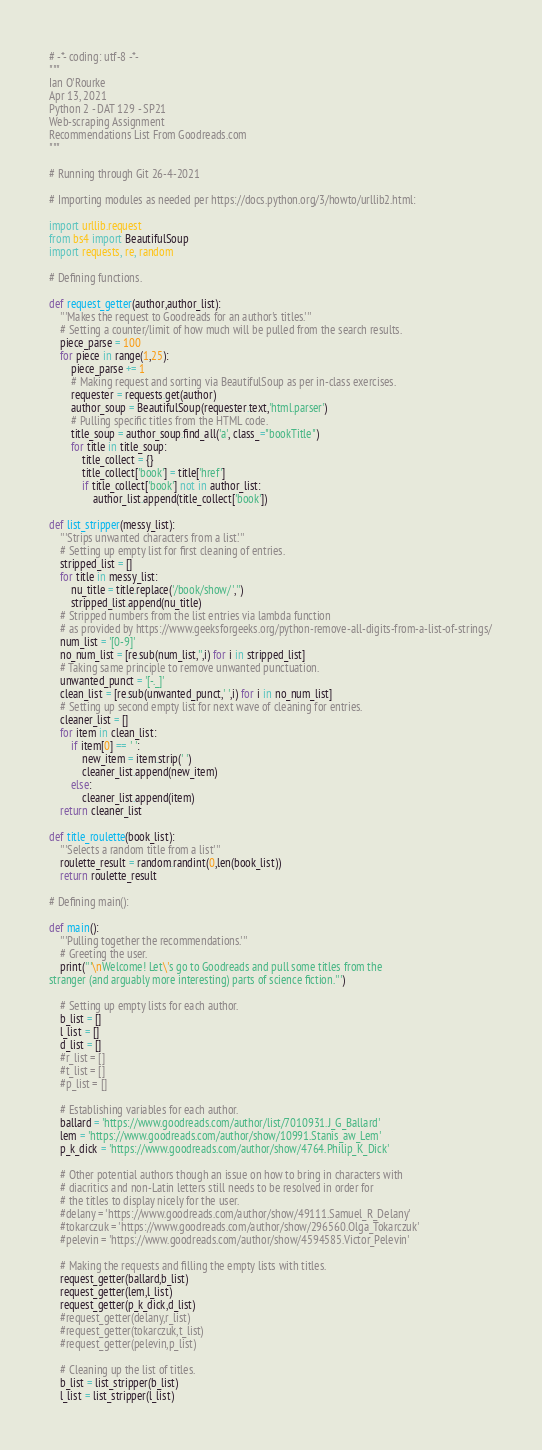Convert code to text. <code><loc_0><loc_0><loc_500><loc_500><_Python_># -*- coding: utf-8 -*-
"""
Ian O'Rourke
Apr 13, 2021
Python 2 - DAT 129 - SP21
Web-scraping Assignment
Recommendations List From Goodreads.com
"""

# Running through Git 26-4-2021

# Importing modules as needed per https://docs.python.org/3/howto/urllib2.html:

import urllib.request
from bs4 import BeautifulSoup
import requests, re, random

# Defining functions.

def request_getter(author,author_list):
    '''Makes the request to Goodreads for an author's titles.'''
    # Setting a counter/limit of how much will be pulled from the search results.
    piece_parse = 100
    for piece in range(1,25):
        piece_parse += 1
        # Making request and sorting via BeautifulSoup as per in-class exercises.
        requester = requests.get(author)
        author_soup = BeautifulSoup(requester.text,'html.parser')
        # Pulling specific titles from the HTML code.
        title_soup = author_soup.find_all('a', class_="bookTitle")
        for title in title_soup:
            title_collect = {}
            title_collect['book'] = title['href']
            if title_collect['book'] not in author_list:
                author_list.append(title_collect['book'])
                
def list_stripper(messy_list):
    '''Strips unwanted characters from a list.'''
    # Setting up empty list for first cleaning of entries.
    stripped_list = []
    for title in messy_list:
        nu_title = title.replace('/book/show/','')
        stripped_list.append(nu_title)
    # Stripped numbers from the list entries via lambda function
    # as provided by https://www.geeksforgeeks.org/python-remove-all-digits-from-a-list-of-strings/
    num_list = '[0-9]'
    no_num_list = [re.sub(num_list,'',i) for i in stripped_list]
    # Taking same principle to remove unwanted punctuation.
    unwanted_punct = '[-._]'
    clean_list = [re.sub(unwanted_punct,' ',i) for i in no_num_list]
    # Setting up second empty list for next wave of cleaning for entries.
    cleaner_list = []
    for item in clean_list:
        if item[0] == ' ':
            new_item = item.strip(' ')
            cleaner_list.append(new_item)
        else:
            cleaner_list.append(item)
    return cleaner_list
                
def title_roulette(book_list):
    '''Selects a random title from a list'''
    roulette_result = random.randint(0,len(book_list))
    return roulette_result

# Defining main():

def main():
    '''Pulling together the recommendations.'''
    # Greeting the user.
    print('''\nWelcome! Let\'s go to Goodreads and pull some titles from the
stranger (and arguably more interesting) parts of science fiction.''')
    
    # Setting up empty lists for each author.
    b_list = []
    l_list = []
    d_list = []
    #r_list = []
    #t_list = []
    #p_list = []
    
    # Establishing variables for each author.    
    ballard = 'https://www.goodreads.com/author/list/7010931.J_G_Ballard'
    lem = 'https://www.goodreads.com/author/show/10991.Stanis_aw_Lem'
    p_k_dick = 'https://www.goodreads.com/author/show/4764.Philip_K_Dick'
    
    # Other potential authors though an issue on how to bring in characters with
    # diacritics and non-Latin letters still needs to be resolved in order for
    # the titles to display nicely for the user.
    #delany = 'https://www.goodreads.com/author/show/49111.Samuel_R_Delany'
    #tokarczuk = 'https://www.goodreads.com/author/show/296560.Olga_Tokarczuk'
    #pelevin = 'https://www.goodreads.com/author/show/4594585.Victor_Pelevin'

    # Making the requests and filling the empty lists with titles.
    request_getter(ballard,b_list)
    request_getter(lem,l_list)
    request_getter(p_k_dick,d_list)
    #request_getter(delany,r_list)
    #request_getter(tokarczuk,t_list)
    #request_getter(pelevin,p_list)
    
    # Cleaning up the list of titles.
    b_list = list_stripper(b_list)
    l_list = list_stripper(l_list)</code> 